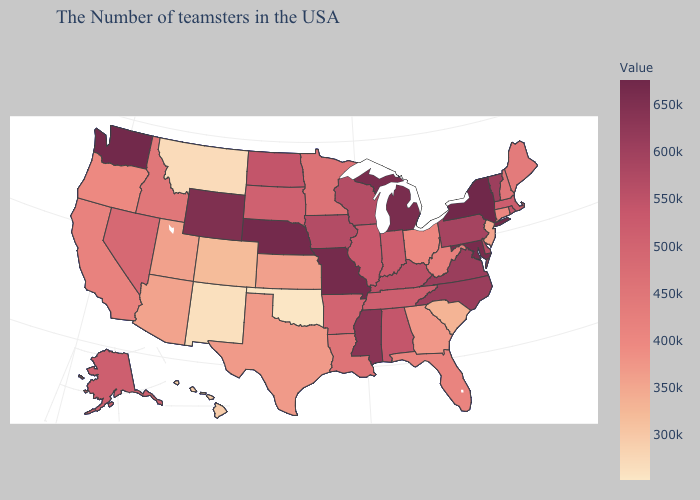Among the states that border New Hampshire , does Vermont have the highest value?
Write a very short answer. Yes. Among the states that border Illinois , which have the lowest value?
Concise answer only. Indiana. Which states have the highest value in the USA?
Answer briefly. New York. Does Vermont have the lowest value in the USA?
Give a very brief answer. No. Among the states that border Arizona , which have the lowest value?
Quick response, please. New Mexico. Does the map have missing data?
Write a very short answer. No. Does Maryland have the lowest value in the USA?
Be succinct. No. 